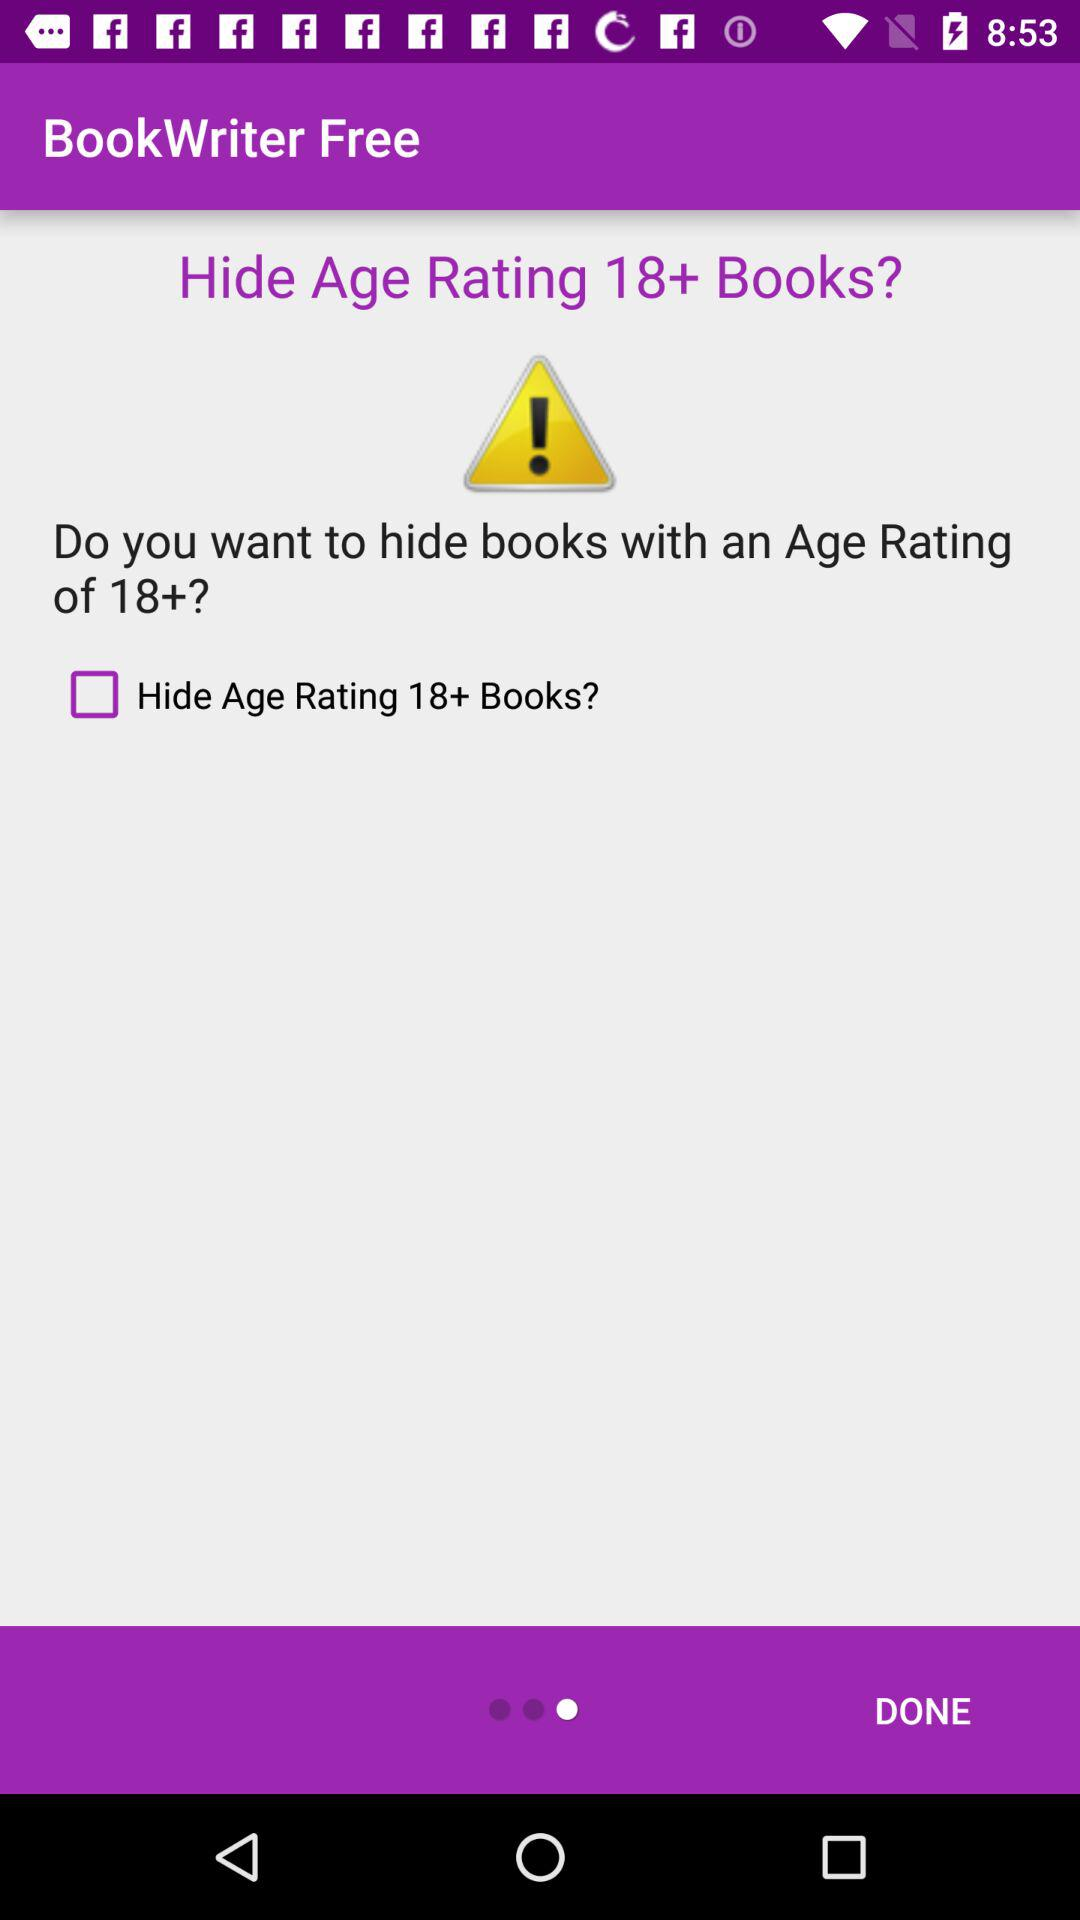What is the name of the application? The name of the application is "BookWriter Free". 